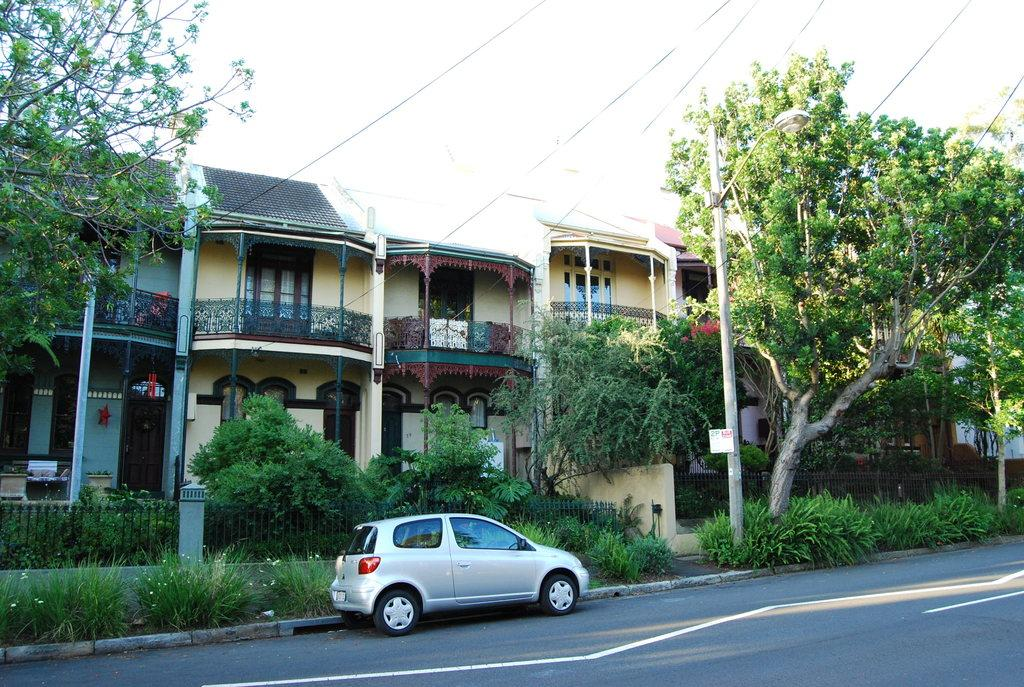What is the main subject of the image? There is a car on the road in the image. What can be seen in the background of the image? There are buildings, trees, and the sky visible in the background of the image. How many sticks are being used by the car to maintain its health in the image? There are no sticks present in the image, and the car's health is not relevant to the image. 